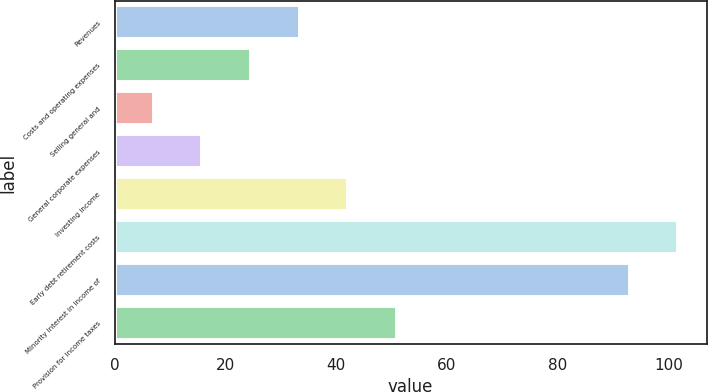<chart> <loc_0><loc_0><loc_500><loc_500><bar_chart><fcel>Revenues<fcel>Costs and operating expenses<fcel>Selling general and<fcel>General corporate expenses<fcel>Investing income<fcel>Early debt retirement costs<fcel>Minority interest in income of<fcel>Provision for income taxes<nl><fcel>33.4<fcel>24.6<fcel>7<fcel>15.8<fcel>42.2<fcel>101.8<fcel>93<fcel>51<nl></chart> 